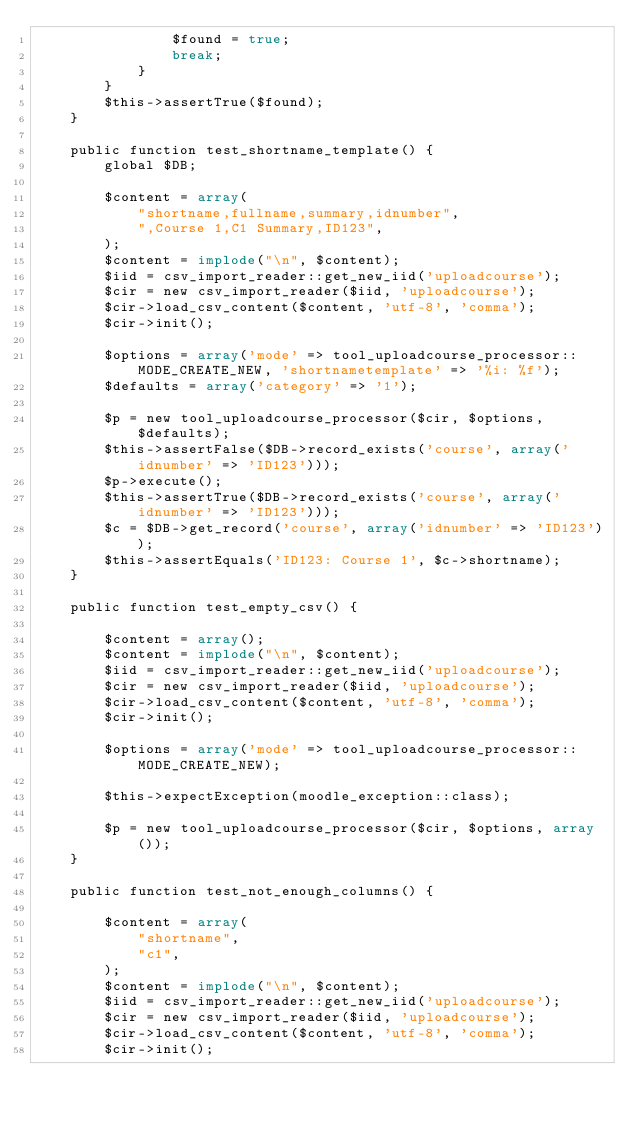Convert code to text. <code><loc_0><loc_0><loc_500><loc_500><_PHP_>                $found = true;
                break;
            }
        }
        $this->assertTrue($found);
    }

    public function test_shortname_template() {
        global $DB;

        $content = array(
            "shortname,fullname,summary,idnumber",
            ",Course 1,C1 Summary,ID123",
        );
        $content = implode("\n", $content);
        $iid = csv_import_reader::get_new_iid('uploadcourse');
        $cir = new csv_import_reader($iid, 'uploadcourse');
        $cir->load_csv_content($content, 'utf-8', 'comma');
        $cir->init();

        $options = array('mode' => tool_uploadcourse_processor::MODE_CREATE_NEW, 'shortnametemplate' => '%i: %f');
        $defaults = array('category' => '1');

        $p = new tool_uploadcourse_processor($cir, $options, $defaults);
        $this->assertFalse($DB->record_exists('course', array('idnumber' => 'ID123')));
        $p->execute();
        $this->assertTrue($DB->record_exists('course', array('idnumber' => 'ID123')));
        $c = $DB->get_record('course', array('idnumber' => 'ID123'));
        $this->assertEquals('ID123: Course 1', $c->shortname);
    }

    public function test_empty_csv() {

        $content = array();
        $content = implode("\n", $content);
        $iid = csv_import_reader::get_new_iid('uploadcourse');
        $cir = new csv_import_reader($iid, 'uploadcourse');
        $cir->load_csv_content($content, 'utf-8', 'comma');
        $cir->init();

        $options = array('mode' => tool_uploadcourse_processor::MODE_CREATE_NEW);

        $this->expectException(moodle_exception::class);

        $p = new tool_uploadcourse_processor($cir, $options, array());
    }

    public function test_not_enough_columns() {

        $content = array(
            "shortname",
            "c1",
        );
        $content = implode("\n", $content);
        $iid = csv_import_reader::get_new_iid('uploadcourse');
        $cir = new csv_import_reader($iid, 'uploadcourse');
        $cir->load_csv_content($content, 'utf-8', 'comma');
        $cir->init();
</code> 